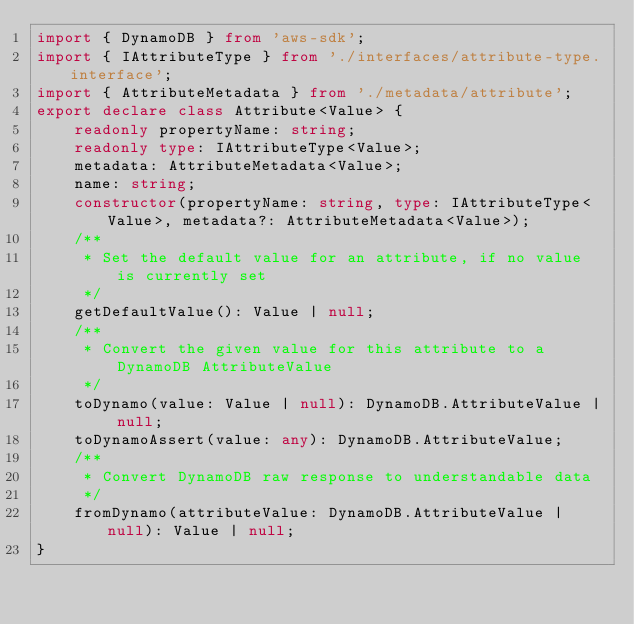Convert code to text. <code><loc_0><loc_0><loc_500><loc_500><_TypeScript_>import { DynamoDB } from 'aws-sdk';
import { IAttributeType } from './interfaces/attribute-type.interface';
import { AttributeMetadata } from './metadata/attribute';
export declare class Attribute<Value> {
    readonly propertyName: string;
    readonly type: IAttributeType<Value>;
    metadata: AttributeMetadata<Value>;
    name: string;
    constructor(propertyName: string, type: IAttributeType<Value>, metadata?: AttributeMetadata<Value>);
    /**
     * Set the default value for an attribute, if no value is currently set
     */
    getDefaultValue(): Value | null;
    /**
     * Convert the given value for this attribute to a DynamoDB AttributeValue
     */
    toDynamo(value: Value | null): DynamoDB.AttributeValue | null;
    toDynamoAssert(value: any): DynamoDB.AttributeValue;
    /**
     * Convert DynamoDB raw response to understandable data
     */
    fromDynamo(attributeValue: DynamoDB.AttributeValue | null): Value | null;
}
</code> 